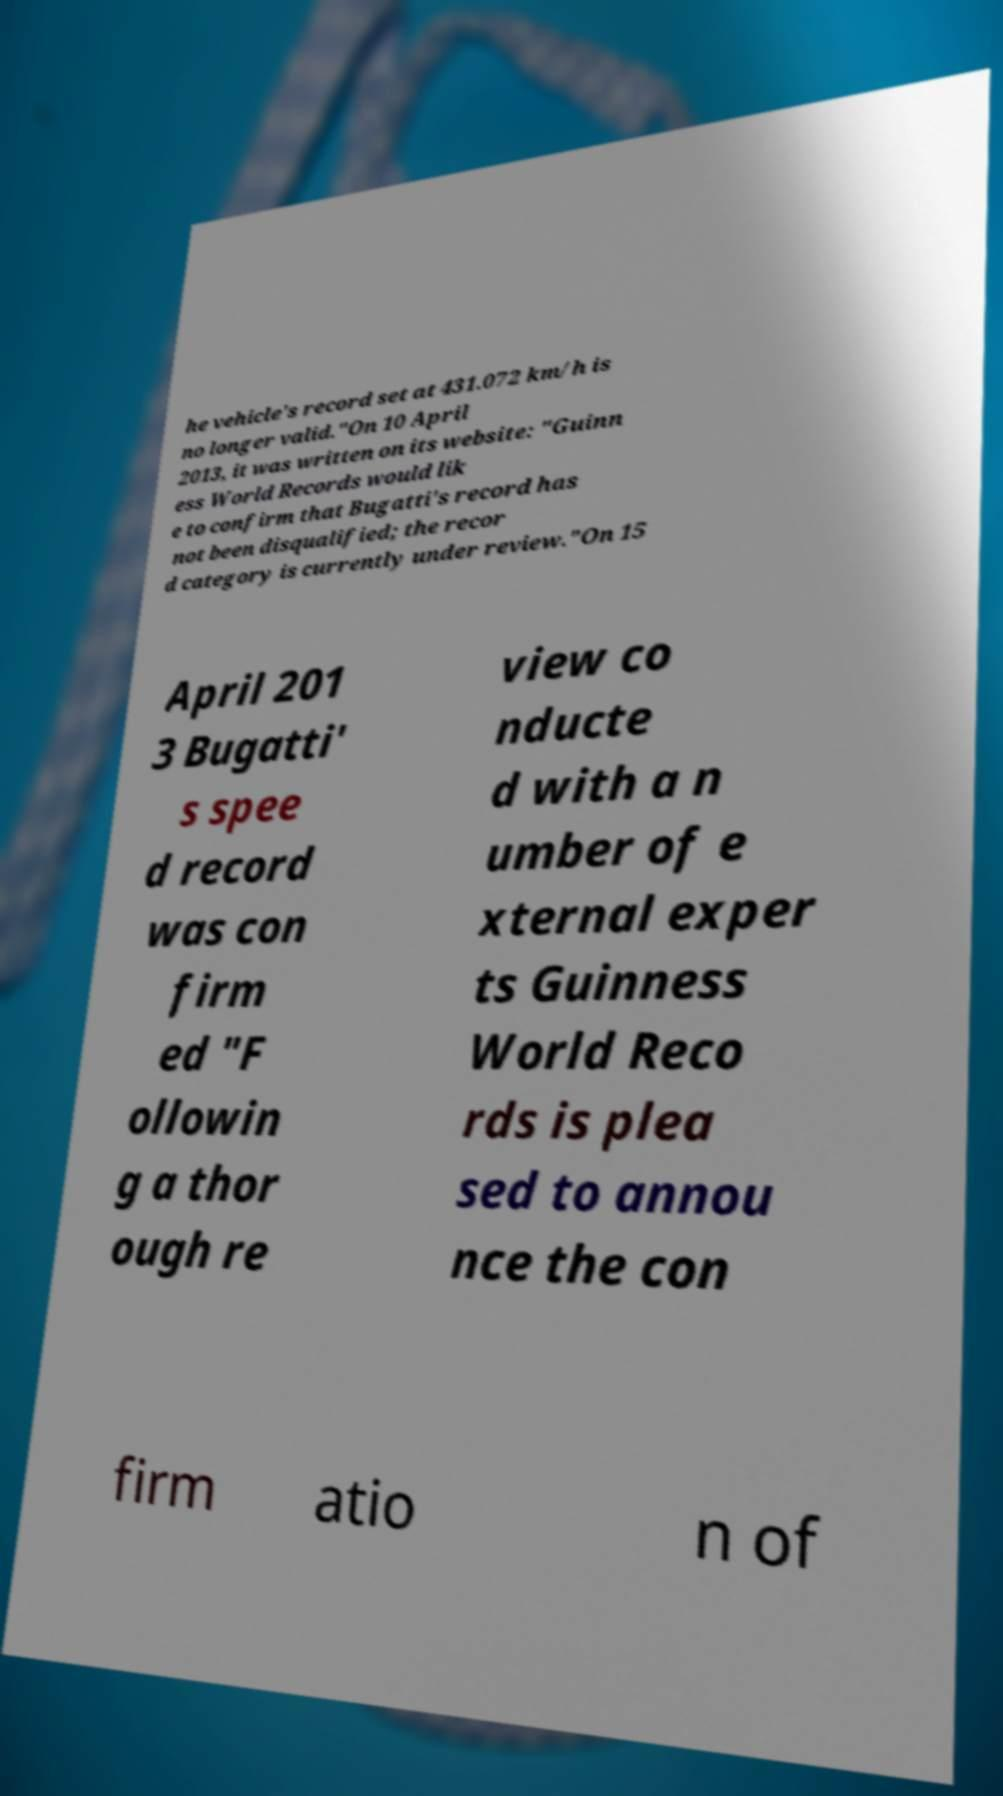Please read and relay the text visible in this image. What does it say? he vehicle's record set at 431.072 km/h is no longer valid."On 10 April 2013, it was written on its website: "Guinn ess World Records would lik e to confirm that Bugatti's record has not been disqualified; the recor d category is currently under review."On 15 April 201 3 Bugatti' s spee d record was con firm ed "F ollowin g a thor ough re view co nducte d with a n umber of e xternal exper ts Guinness World Reco rds is plea sed to annou nce the con firm atio n of 